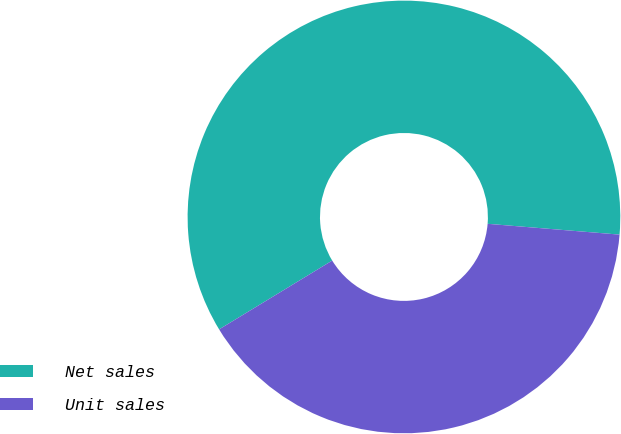Convert chart to OTSL. <chart><loc_0><loc_0><loc_500><loc_500><pie_chart><fcel>Net sales<fcel>Unit sales<nl><fcel>60.0%<fcel>40.0%<nl></chart> 